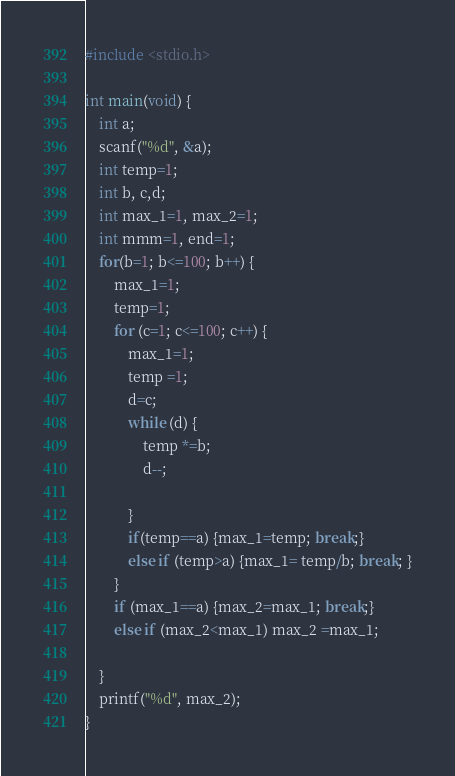Convert code to text. <code><loc_0><loc_0><loc_500><loc_500><_C_>#include <stdio.h>

int main(void) {
    int a;
	scanf("%d", &a);
	int temp=1;
	int b, c,d;
	int max_1=1, max_2=1;
	int mmm=1, end=1;
	for(b=1; b<=100; b++) {
		max_1=1;
		temp=1;
		for (c=1; c<=100; c++) {
			max_1=1;
	    	temp =1;
			d=c;
	    	while (d) {
	    		temp *=b;
		    	d--;
		
	    	}
			if(temp==a) {max_1=temp; break;}
			else if (temp>a) {max_1= temp/b; break; }
		}
		if (max_1==a) {max_2=max_1; break;}
		else if (max_2<max_1) max_2 =max_1;
		
	}   
	printf("%d", max_2);
}</code> 